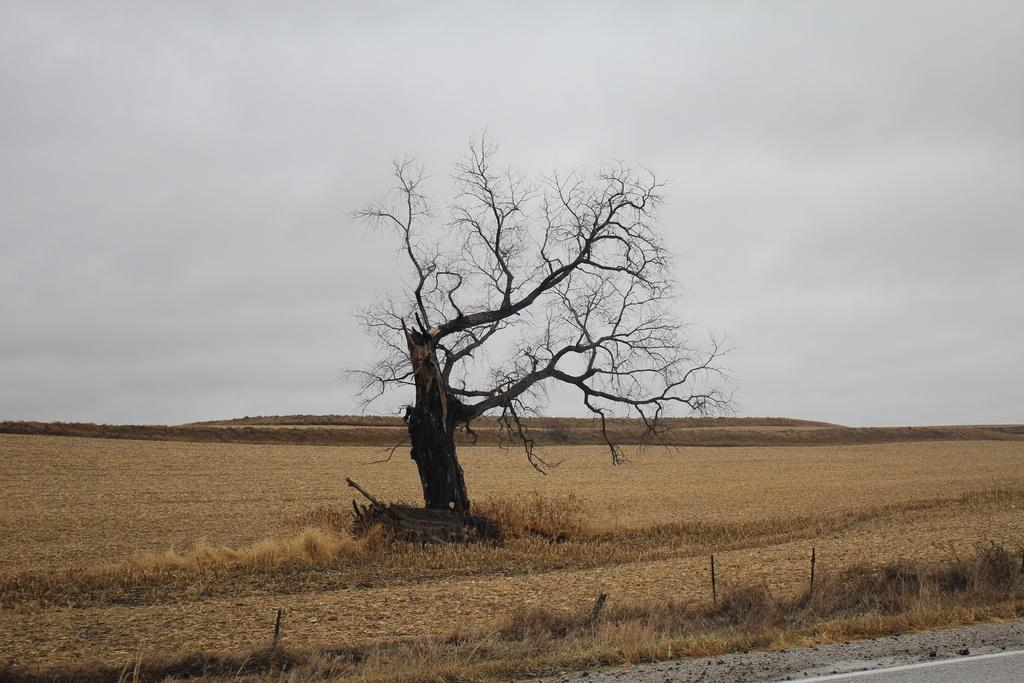What type of vegetation is present at the bottom of the image? There is grass on the ground at the bottom of the image. What can be seen in the image besides the grass? There is a tree without leaves in the image. What is visible at the top of the image? The sky is visible at the top of the image. What type of cabbage is growing on the tree in the image? There is no cabbage present in the image; it features a tree without leaves. What caused the tree to lose its leaves in the image? The provided facts do not mention the cause of the tree losing its leaves, so we cannot determine the reason from the image. 